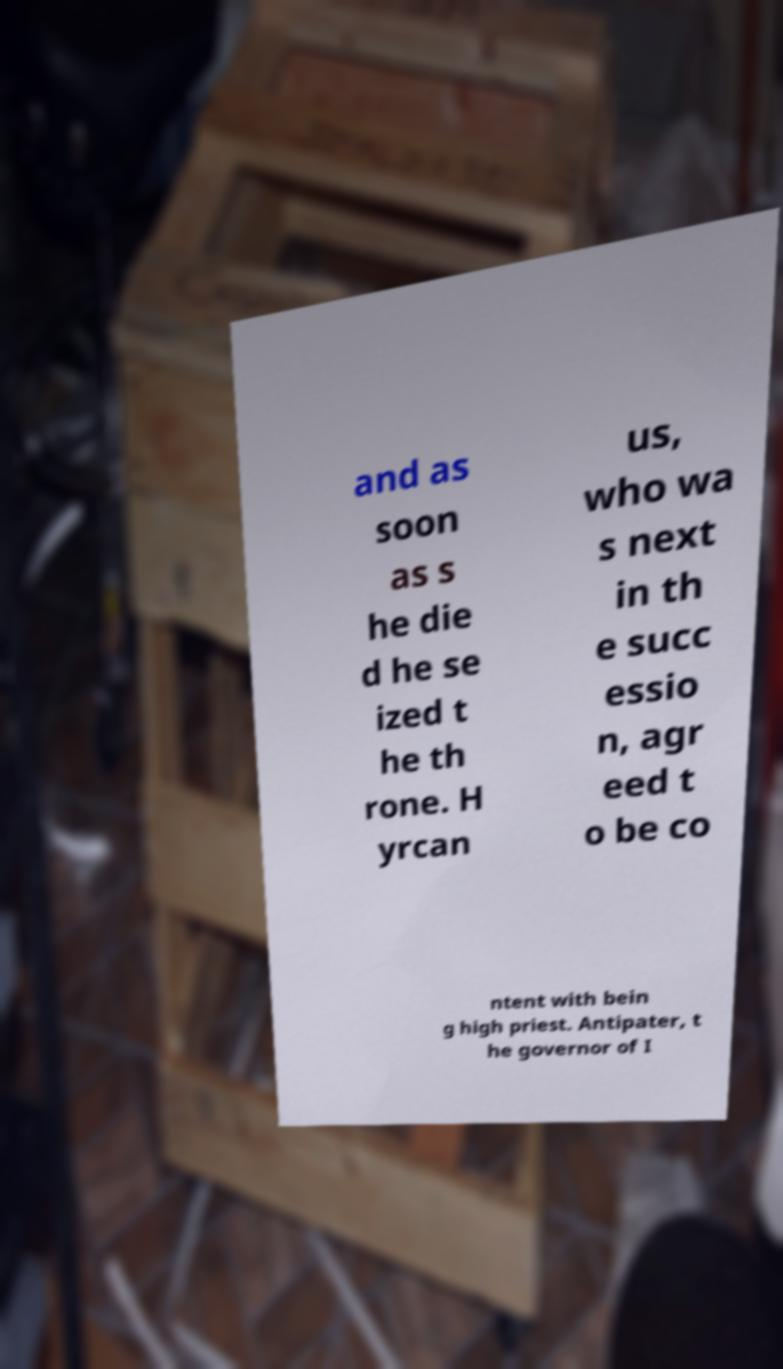What messages or text are displayed in this image? I need them in a readable, typed format. and as soon as s he die d he se ized t he th rone. H yrcan us, who wa s next in th e succ essio n, agr eed t o be co ntent with bein g high priest. Antipater, t he governor of I 